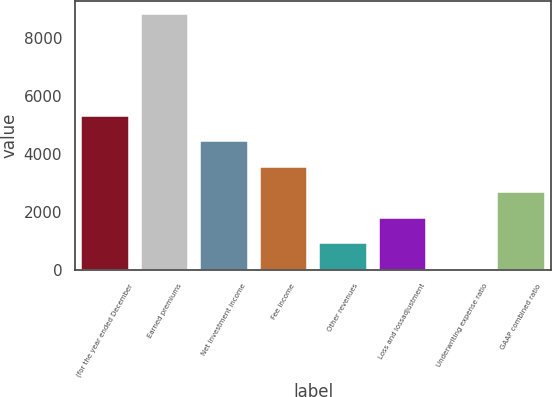<chart> <loc_0><loc_0><loc_500><loc_500><bar_chart><fcel>(for the year ended December<fcel>Earned premiums<fcel>Net investment income<fcel>Fee income<fcel>Other revenues<fcel>Loss and lossadjustment<fcel>Underwriting expense ratio<fcel>GAAP combined ratio<nl><fcel>5300.72<fcel>8816<fcel>4421.9<fcel>3543.08<fcel>906.62<fcel>1785.44<fcel>27.8<fcel>2664.26<nl></chart> 